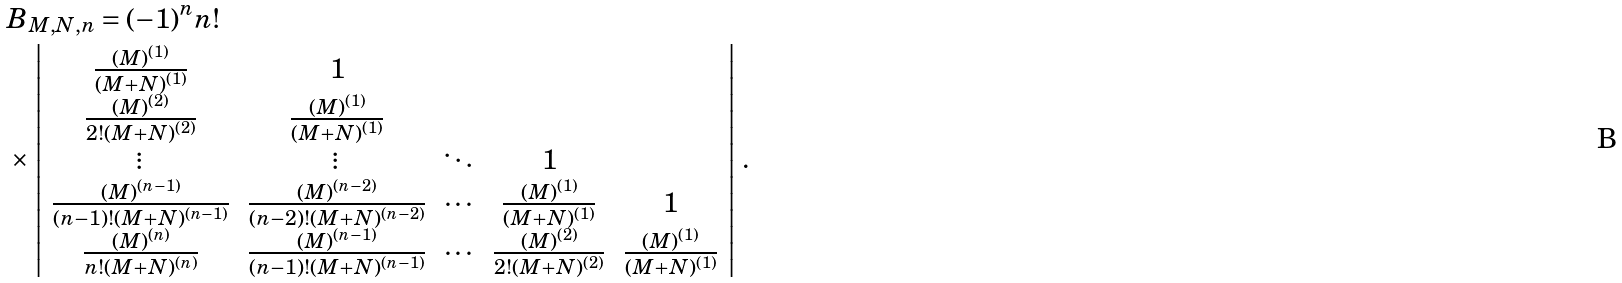Convert formula to latex. <formula><loc_0><loc_0><loc_500><loc_500>& B _ { M , N , n } = ( - 1 ) ^ { n } n ! \\ & \times \left | \begin{array} { c c c c c } \frac { ( M ) ^ { ( 1 ) } } { ( M + N ) ^ { ( 1 ) } } & 1 & & & \\ \frac { ( M ) ^ { ( 2 ) } } { 2 ! ( M + N ) ^ { ( 2 ) } } & \frac { ( M ) ^ { ( 1 ) } } { ( M + N ) ^ { ( 1 ) } } & & & \\ \vdots & \vdots & \ddots & 1 & \\ \frac { ( M ) ^ { ( n - 1 ) } } { ( n - 1 ) ! ( M + N ) ^ { ( n - 1 ) } } & \frac { ( M ) ^ { ( n - 2 ) } } { ( n - 2 ) ! ( M + N ) ^ { ( n - 2 ) } } & \cdots & \frac { ( M ) ^ { ( 1 ) } } { ( M + N ) ^ { ( 1 ) } } & 1 \\ \frac { ( M ) ^ { ( n ) } } { n ! ( M + N ) ^ { ( n ) } } & \frac { ( M ) ^ { ( n - 1 ) } } { ( n - 1 ) ! ( M + N ) ^ { ( n - 1 ) } } & \cdots & \frac { ( M ) ^ { ( 2 ) } } { 2 ! ( M + N ) ^ { ( 2 ) } } & \frac { ( M ) ^ { ( 1 ) } } { ( M + N ) ^ { ( 1 ) } } \end{array} \right | \, .</formula> 